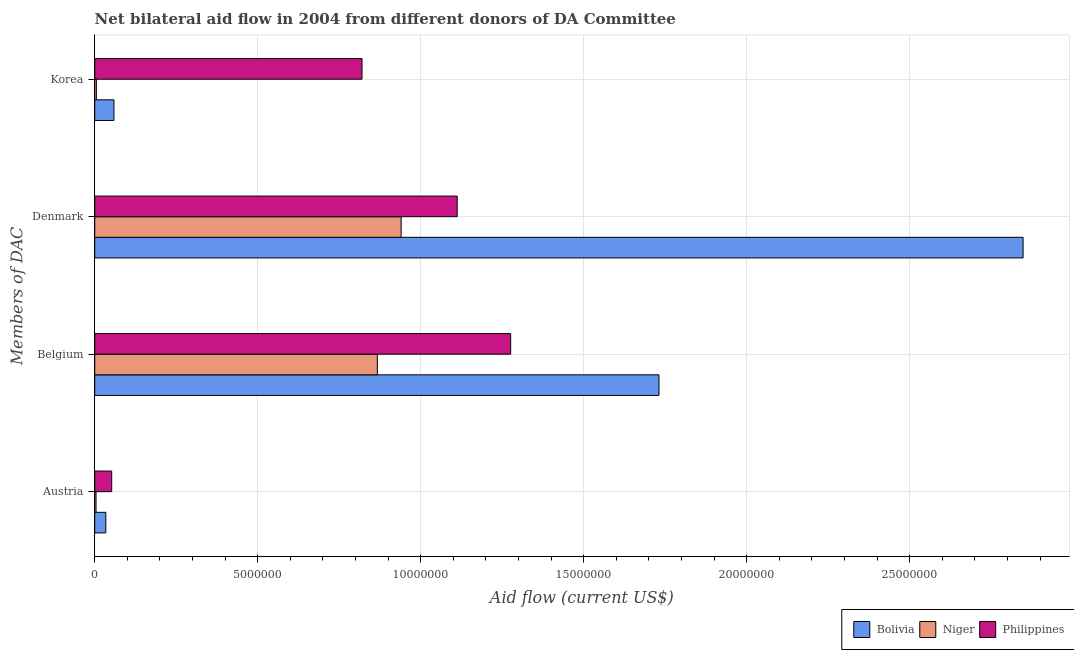Are the number of bars per tick equal to the number of legend labels?
Offer a very short reply. Yes. How many bars are there on the 2nd tick from the top?
Offer a very short reply. 3. What is the label of the 2nd group of bars from the top?
Make the answer very short. Denmark. What is the amount of aid given by korea in Niger?
Your answer should be very brief. 5.00e+04. Across all countries, what is the maximum amount of aid given by austria?
Provide a succinct answer. 5.20e+05. Across all countries, what is the minimum amount of aid given by denmark?
Your answer should be very brief. 9.40e+06. In which country was the amount of aid given by denmark minimum?
Provide a short and direct response. Niger. What is the total amount of aid given by belgium in the graph?
Offer a very short reply. 3.87e+07. What is the difference between the amount of aid given by korea in Philippines and that in Niger?
Offer a very short reply. 8.15e+06. What is the difference between the amount of aid given by denmark in Bolivia and the amount of aid given by korea in Niger?
Make the answer very short. 2.84e+07. What is the average amount of aid given by denmark per country?
Your answer should be very brief. 1.63e+07. What is the difference between the amount of aid given by austria and amount of aid given by belgium in Niger?
Provide a short and direct response. -8.63e+06. What is the ratio of the amount of aid given by korea in Niger to that in Bolivia?
Provide a succinct answer. 0.08. What is the difference between the highest and the second highest amount of aid given by denmark?
Keep it short and to the point. 1.74e+07. What is the difference between the highest and the lowest amount of aid given by belgium?
Make the answer very short. 8.64e+06. Is the sum of the amount of aid given by belgium in Philippines and Niger greater than the maximum amount of aid given by denmark across all countries?
Offer a very short reply. No. Is it the case that in every country, the sum of the amount of aid given by korea and amount of aid given by austria is greater than the sum of amount of aid given by denmark and amount of aid given by belgium?
Provide a short and direct response. No. What does the 3rd bar from the top in Denmark represents?
Your answer should be compact. Bolivia. What does the 1st bar from the bottom in Belgium represents?
Provide a succinct answer. Bolivia. Is it the case that in every country, the sum of the amount of aid given by austria and amount of aid given by belgium is greater than the amount of aid given by denmark?
Ensure brevity in your answer.  No. How many bars are there?
Give a very brief answer. 12. How many countries are there in the graph?
Make the answer very short. 3. Does the graph contain grids?
Give a very brief answer. Yes. How many legend labels are there?
Give a very brief answer. 3. What is the title of the graph?
Keep it short and to the point. Net bilateral aid flow in 2004 from different donors of DA Committee. What is the label or title of the Y-axis?
Offer a very short reply. Members of DAC. What is the Aid flow (current US$) of Niger in Austria?
Make the answer very short. 4.00e+04. What is the Aid flow (current US$) in Philippines in Austria?
Your answer should be very brief. 5.20e+05. What is the Aid flow (current US$) of Bolivia in Belgium?
Ensure brevity in your answer.  1.73e+07. What is the Aid flow (current US$) of Niger in Belgium?
Your answer should be very brief. 8.67e+06. What is the Aid flow (current US$) in Philippines in Belgium?
Make the answer very short. 1.28e+07. What is the Aid flow (current US$) of Bolivia in Denmark?
Make the answer very short. 2.85e+07. What is the Aid flow (current US$) of Niger in Denmark?
Provide a short and direct response. 9.40e+06. What is the Aid flow (current US$) in Philippines in Denmark?
Your answer should be very brief. 1.11e+07. What is the Aid flow (current US$) in Bolivia in Korea?
Your response must be concise. 5.90e+05. What is the Aid flow (current US$) in Philippines in Korea?
Your response must be concise. 8.20e+06. Across all Members of DAC, what is the maximum Aid flow (current US$) of Bolivia?
Your answer should be very brief. 2.85e+07. Across all Members of DAC, what is the maximum Aid flow (current US$) of Niger?
Keep it short and to the point. 9.40e+06. Across all Members of DAC, what is the maximum Aid flow (current US$) of Philippines?
Keep it short and to the point. 1.28e+07. Across all Members of DAC, what is the minimum Aid flow (current US$) in Bolivia?
Your answer should be very brief. 3.40e+05. Across all Members of DAC, what is the minimum Aid flow (current US$) in Philippines?
Your answer should be compact. 5.20e+05. What is the total Aid flow (current US$) in Bolivia in the graph?
Provide a short and direct response. 4.67e+07. What is the total Aid flow (current US$) of Niger in the graph?
Provide a succinct answer. 1.82e+07. What is the total Aid flow (current US$) in Philippines in the graph?
Keep it short and to the point. 3.26e+07. What is the difference between the Aid flow (current US$) of Bolivia in Austria and that in Belgium?
Your response must be concise. -1.70e+07. What is the difference between the Aid flow (current US$) of Niger in Austria and that in Belgium?
Provide a succinct answer. -8.63e+06. What is the difference between the Aid flow (current US$) in Philippines in Austria and that in Belgium?
Provide a short and direct response. -1.22e+07. What is the difference between the Aid flow (current US$) in Bolivia in Austria and that in Denmark?
Ensure brevity in your answer.  -2.81e+07. What is the difference between the Aid flow (current US$) in Niger in Austria and that in Denmark?
Ensure brevity in your answer.  -9.36e+06. What is the difference between the Aid flow (current US$) of Philippines in Austria and that in Denmark?
Provide a short and direct response. -1.06e+07. What is the difference between the Aid flow (current US$) in Niger in Austria and that in Korea?
Your answer should be compact. -10000. What is the difference between the Aid flow (current US$) in Philippines in Austria and that in Korea?
Offer a very short reply. -7.68e+06. What is the difference between the Aid flow (current US$) of Bolivia in Belgium and that in Denmark?
Your response must be concise. -1.12e+07. What is the difference between the Aid flow (current US$) of Niger in Belgium and that in Denmark?
Offer a very short reply. -7.30e+05. What is the difference between the Aid flow (current US$) of Philippines in Belgium and that in Denmark?
Give a very brief answer. 1.64e+06. What is the difference between the Aid flow (current US$) in Bolivia in Belgium and that in Korea?
Provide a short and direct response. 1.67e+07. What is the difference between the Aid flow (current US$) of Niger in Belgium and that in Korea?
Provide a short and direct response. 8.62e+06. What is the difference between the Aid flow (current US$) of Philippines in Belgium and that in Korea?
Give a very brief answer. 4.56e+06. What is the difference between the Aid flow (current US$) of Bolivia in Denmark and that in Korea?
Make the answer very short. 2.79e+07. What is the difference between the Aid flow (current US$) in Niger in Denmark and that in Korea?
Provide a succinct answer. 9.35e+06. What is the difference between the Aid flow (current US$) of Philippines in Denmark and that in Korea?
Make the answer very short. 2.92e+06. What is the difference between the Aid flow (current US$) of Bolivia in Austria and the Aid flow (current US$) of Niger in Belgium?
Ensure brevity in your answer.  -8.33e+06. What is the difference between the Aid flow (current US$) of Bolivia in Austria and the Aid flow (current US$) of Philippines in Belgium?
Provide a short and direct response. -1.24e+07. What is the difference between the Aid flow (current US$) of Niger in Austria and the Aid flow (current US$) of Philippines in Belgium?
Give a very brief answer. -1.27e+07. What is the difference between the Aid flow (current US$) of Bolivia in Austria and the Aid flow (current US$) of Niger in Denmark?
Your answer should be compact. -9.06e+06. What is the difference between the Aid flow (current US$) of Bolivia in Austria and the Aid flow (current US$) of Philippines in Denmark?
Offer a very short reply. -1.08e+07. What is the difference between the Aid flow (current US$) of Niger in Austria and the Aid flow (current US$) of Philippines in Denmark?
Offer a very short reply. -1.11e+07. What is the difference between the Aid flow (current US$) in Bolivia in Austria and the Aid flow (current US$) in Niger in Korea?
Offer a terse response. 2.90e+05. What is the difference between the Aid flow (current US$) of Bolivia in Austria and the Aid flow (current US$) of Philippines in Korea?
Ensure brevity in your answer.  -7.86e+06. What is the difference between the Aid flow (current US$) of Niger in Austria and the Aid flow (current US$) of Philippines in Korea?
Give a very brief answer. -8.16e+06. What is the difference between the Aid flow (current US$) in Bolivia in Belgium and the Aid flow (current US$) in Niger in Denmark?
Provide a succinct answer. 7.91e+06. What is the difference between the Aid flow (current US$) in Bolivia in Belgium and the Aid flow (current US$) in Philippines in Denmark?
Make the answer very short. 6.19e+06. What is the difference between the Aid flow (current US$) in Niger in Belgium and the Aid flow (current US$) in Philippines in Denmark?
Offer a terse response. -2.45e+06. What is the difference between the Aid flow (current US$) of Bolivia in Belgium and the Aid flow (current US$) of Niger in Korea?
Offer a very short reply. 1.73e+07. What is the difference between the Aid flow (current US$) in Bolivia in Belgium and the Aid flow (current US$) in Philippines in Korea?
Provide a short and direct response. 9.11e+06. What is the difference between the Aid flow (current US$) of Niger in Belgium and the Aid flow (current US$) of Philippines in Korea?
Provide a short and direct response. 4.70e+05. What is the difference between the Aid flow (current US$) of Bolivia in Denmark and the Aid flow (current US$) of Niger in Korea?
Your response must be concise. 2.84e+07. What is the difference between the Aid flow (current US$) in Bolivia in Denmark and the Aid flow (current US$) in Philippines in Korea?
Provide a short and direct response. 2.03e+07. What is the difference between the Aid flow (current US$) in Niger in Denmark and the Aid flow (current US$) in Philippines in Korea?
Your response must be concise. 1.20e+06. What is the average Aid flow (current US$) of Bolivia per Members of DAC?
Your response must be concise. 1.17e+07. What is the average Aid flow (current US$) of Niger per Members of DAC?
Your response must be concise. 4.54e+06. What is the average Aid flow (current US$) in Philippines per Members of DAC?
Your response must be concise. 8.15e+06. What is the difference between the Aid flow (current US$) of Bolivia and Aid flow (current US$) of Niger in Austria?
Your answer should be compact. 3.00e+05. What is the difference between the Aid flow (current US$) in Niger and Aid flow (current US$) in Philippines in Austria?
Your answer should be compact. -4.80e+05. What is the difference between the Aid flow (current US$) in Bolivia and Aid flow (current US$) in Niger in Belgium?
Ensure brevity in your answer.  8.64e+06. What is the difference between the Aid flow (current US$) of Bolivia and Aid flow (current US$) of Philippines in Belgium?
Your response must be concise. 4.55e+06. What is the difference between the Aid flow (current US$) in Niger and Aid flow (current US$) in Philippines in Belgium?
Make the answer very short. -4.09e+06. What is the difference between the Aid flow (current US$) in Bolivia and Aid flow (current US$) in Niger in Denmark?
Give a very brief answer. 1.91e+07. What is the difference between the Aid flow (current US$) in Bolivia and Aid flow (current US$) in Philippines in Denmark?
Offer a very short reply. 1.74e+07. What is the difference between the Aid flow (current US$) of Niger and Aid flow (current US$) of Philippines in Denmark?
Keep it short and to the point. -1.72e+06. What is the difference between the Aid flow (current US$) in Bolivia and Aid flow (current US$) in Niger in Korea?
Your response must be concise. 5.40e+05. What is the difference between the Aid flow (current US$) of Bolivia and Aid flow (current US$) of Philippines in Korea?
Offer a very short reply. -7.61e+06. What is the difference between the Aid flow (current US$) of Niger and Aid flow (current US$) of Philippines in Korea?
Your answer should be compact. -8.15e+06. What is the ratio of the Aid flow (current US$) of Bolivia in Austria to that in Belgium?
Offer a very short reply. 0.02. What is the ratio of the Aid flow (current US$) in Niger in Austria to that in Belgium?
Make the answer very short. 0. What is the ratio of the Aid flow (current US$) in Philippines in Austria to that in Belgium?
Provide a succinct answer. 0.04. What is the ratio of the Aid flow (current US$) in Bolivia in Austria to that in Denmark?
Ensure brevity in your answer.  0.01. What is the ratio of the Aid flow (current US$) of Niger in Austria to that in Denmark?
Your response must be concise. 0. What is the ratio of the Aid flow (current US$) of Philippines in Austria to that in Denmark?
Keep it short and to the point. 0.05. What is the ratio of the Aid flow (current US$) in Bolivia in Austria to that in Korea?
Offer a terse response. 0.58. What is the ratio of the Aid flow (current US$) of Philippines in Austria to that in Korea?
Offer a very short reply. 0.06. What is the ratio of the Aid flow (current US$) of Bolivia in Belgium to that in Denmark?
Your response must be concise. 0.61. What is the ratio of the Aid flow (current US$) in Niger in Belgium to that in Denmark?
Your answer should be compact. 0.92. What is the ratio of the Aid flow (current US$) in Philippines in Belgium to that in Denmark?
Keep it short and to the point. 1.15. What is the ratio of the Aid flow (current US$) of Bolivia in Belgium to that in Korea?
Offer a very short reply. 29.34. What is the ratio of the Aid flow (current US$) of Niger in Belgium to that in Korea?
Keep it short and to the point. 173.4. What is the ratio of the Aid flow (current US$) of Philippines in Belgium to that in Korea?
Give a very brief answer. 1.56. What is the ratio of the Aid flow (current US$) in Bolivia in Denmark to that in Korea?
Give a very brief answer. 48.27. What is the ratio of the Aid flow (current US$) of Niger in Denmark to that in Korea?
Offer a very short reply. 188. What is the ratio of the Aid flow (current US$) in Philippines in Denmark to that in Korea?
Your answer should be compact. 1.36. What is the difference between the highest and the second highest Aid flow (current US$) of Bolivia?
Your response must be concise. 1.12e+07. What is the difference between the highest and the second highest Aid flow (current US$) in Niger?
Your answer should be compact. 7.30e+05. What is the difference between the highest and the second highest Aid flow (current US$) of Philippines?
Make the answer very short. 1.64e+06. What is the difference between the highest and the lowest Aid flow (current US$) of Bolivia?
Your answer should be compact. 2.81e+07. What is the difference between the highest and the lowest Aid flow (current US$) in Niger?
Your response must be concise. 9.36e+06. What is the difference between the highest and the lowest Aid flow (current US$) of Philippines?
Give a very brief answer. 1.22e+07. 